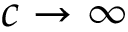Convert formula to latex. <formula><loc_0><loc_0><loc_500><loc_500>c \to \infty</formula> 